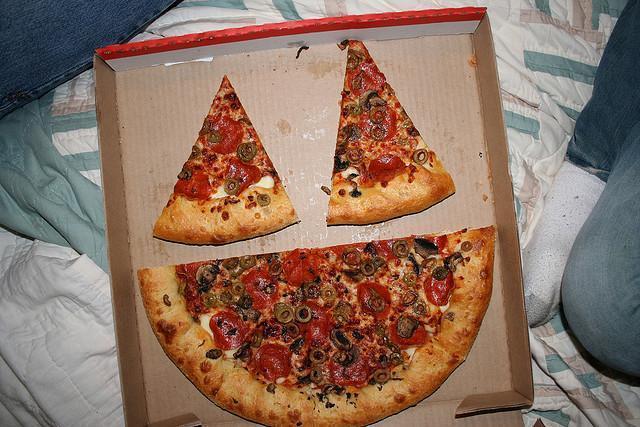How many single slices are there?
Give a very brief answer. 2. How many slices of pizza are there?
Give a very brief answer. 2. How many pizzas can you see?
Give a very brief answer. 3. 